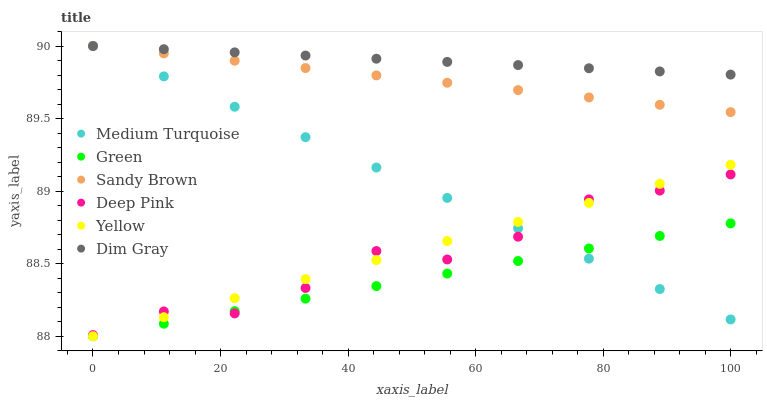Does Green have the minimum area under the curve?
Answer yes or no. Yes. Does Dim Gray have the maximum area under the curve?
Answer yes or no. Yes. Does Yellow have the minimum area under the curve?
Answer yes or no. No. Does Yellow have the maximum area under the curve?
Answer yes or no. No. Is Medium Turquoise the smoothest?
Answer yes or no. Yes. Is Deep Pink the roughest?
Answer yes or no. Yes. Is Yellow the smoothest?
Answer yes or no. No. Is Yellow the roughest?
Answer yes or no. No. Does Yellow have the lowest value?
Answer yes or no. Yes. Does Deep Pink have the lowest value?
Answer yes or no. No. Does Sandy Brown have the highest value?
Answer yes or no. Yes. Does Yellow have the highest value?
Answer yes or no. No. Is Yellow less than Dim Gray?
Answer yes or no. Yes. Is Dim Gray greater than Yellow?
Answer yes or no. Yes. Does Medium Turquoise intersect Sandy Brown?
Answer yes or no. Yes. Is Medium Turquoise less than Sandy Brown?
Answer yes or no. No. Is Medium Turquoise greater than Sandy Brown?
Answer yes or no. No. Does Yellow intersect Dim Gray?
Answer yes or no. No. 